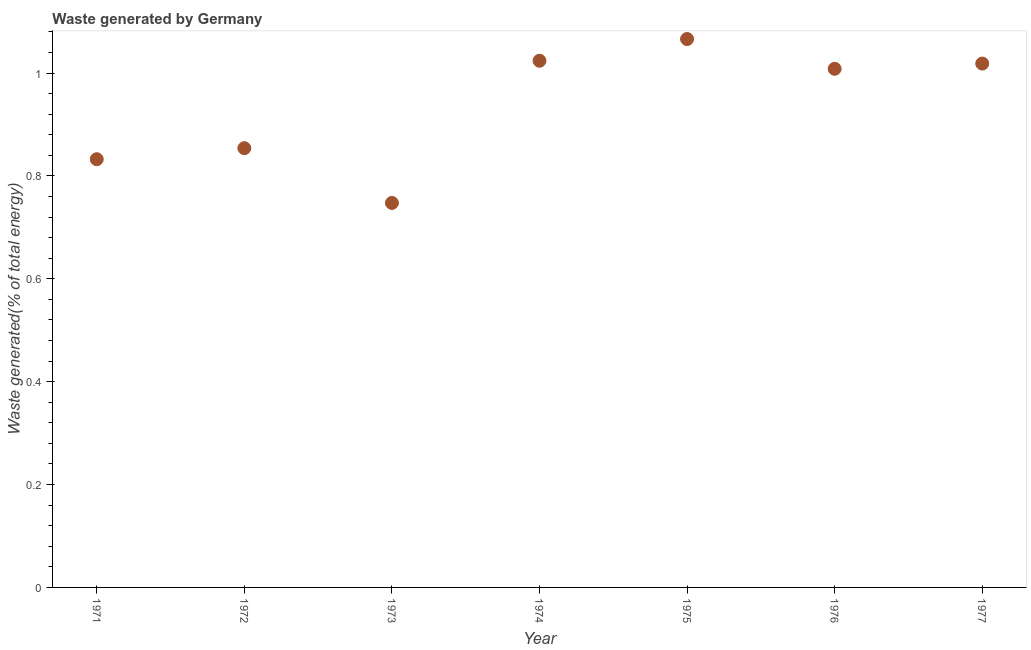What is the amount of waste generated in 1977?
Your answer should be compact. 1.02. Across all years, what is the maximum amount of waste generated?
Your response must be concise. 1.07. Across all years, what is the minimum amount of waste generated?
Provide a short and direct response. 0.75. In which year was the amount of waste generated maximum?
Offer a terse response. 1975. What is the sum of the amount of waste generated?
Your answer should be compact. 6.55. What is the difference between the amount of waste generated in 1971 and 1977?
Make the answer very short. -0.19. What is the average amount of waste generated per year?
Your answer should be compact. 0.94. What is the median amount of waste generated?
Your answer should be very brief. 1.01. Do a majority of the years between 1971 and 1973 (inclusive) have amount of waste generated greater than 0.8400000000000001 %?
Make the answer very short. No. What is the ratio of the amount of waste generated in 1976 to that in 1977?
Your answer should be very brief. 0.99. What is the difference between the highest and the second highest amount of waste generated?
Keep it short and to the point. 0.04. What is the difference between the highest and the lowest amount of waste generated?
Keep it short and to the point. 0.32. In how many years, is the amount of waste generated greater than the average amount of waste generated taken over all years?
Your answer should be compact. 4. Does the amount of waste generated monotonically increase over the years?
Keep it short and to the point. No. How many dotlines are there?
Your answer should be very brief. 1. What is the difference between two consecutive major ticks on the Y-axis?
Your response must be concise. 0.2. What is the title of the graph?
Your answer should be very brief. Waste generated by Germany. What is the label or title of the X-axis?
Provide a short and direct response. Year. What is the label or title of the Y-axis?
Offer a very short reply. Waste generated(% of total energy). What is the Waste generated(% of total energy) in 1971?
Provide a short and direct response. 0.83. What is the Waste generated(% of total energy) in 1972?
Keep it short and to the point. 0.85. What is the Waste generated(% of total energy) in 1973?
Offer a terse response. 0.75. What is the Waste generated(% of total energy) in 1974?
Offer a very short reply. 1.02. What is the Waste generated(% of total energy) in 1975?
Your answer should be compact. 1.07. What is the Waste generated(% of total energy) in 1976?
Offer a terse response. 1.01. What is the Waste generated(% of total energy) in 1977?
Give a very brief answer. 1.02. What is the difference between the Waste generated(% of total energy) in 1971 and 1972?
Make the answer very short. -0.02. What is the difference between the Waste generated(% of total energy) in 1971 and 1973?
Your answer should be very brief. 0.09. What is the difference between the Waste generated(% of total energy) in 1971 and 1974?
Make the answer very short. -0.19. What is the difference between the Waste generated(% of total energy) in 1971 and 1975?
Offer a terse response. -0.23. What is the difference between the Waste generated(% of total energy) in 1971 and 1976?
Make the answer very short. -0.18. What is the difference between the Waste generated(% of total energy) in 1971 and 1977?
Offer a terse response. -0.19. What is the difference between the Waste generated(% of total energy) in 1972 and 1973?
Your answer should be very brief. 0.11. What is the difference between the Waste generated(% of total energy) in 1972 and 1974?
Provide a succinct answer. -0.17. What is the difference between the Waste generated(% of total energy) in 1972 and 1975?
Your answer should be very brief. -0.21. What is the difference between the Waste generated(% of total energy) in 1972 and 1976?
Your response must be concise. -0.15. What is the difference between the Waste generated(% of total energy) in 1972 and 1977?
Your answer should be very brief. -0.16. What is the difference between the Waste generated(% of total energy) in 1973 and 1974?
Make the answer very short. -0.28. What is the difference between the Waste generated(% of total energy) in 1973 and 1975?
Your answer should be compact. -0.32. What is the difference between the Waste generated(% of total energy) in 1973 and 1976?
Offer a very short reply. -0.26. What is the difference between the Waste generated(% of total energy) in 1973 and 1977?
Offer a terse response. -0.27. What is the difference between the Waste generated(% of total energy) in 1974 and 1975?
Provide a succinct answer. -0.04. What is the difference between the Waste generated(% of total energy) in 1974 and 1976?
Provide a short and direct response. 0.02. What is the difference between the Waste generated(% of total energy) in 1974 and 1977?
Offer a terse response. 0.01. What is the difference between the Waste generated(% of total energy) in 1975 and 1976?
Provide a short and direct response. 0.06. What is the difference between the Waste generated(% of total energy) in 1975 and 1977?
Provide a succinct answer. 0.05. What is the difference between the Waste generated(% of total energy) in 1976 and 1977?
Keep it short and to the point. -0.01. What is the ratio of the Waste generated(% of total energy) in 1971 to that in 1973?
Make the answer very short. 1.11. What is the ratio of the Waste generated(% of total energy) in 1971 to that in 1974?
Offer a terse response. 0.81. What is the ratio of the Waste generated(% of total energy) in 1971 to that in 1975?
Give a very brief answer. 0.78. What is the ratio of the Waste generated(% of total energy) in 1971 to that in 1976?
Your response must be concise. 0.83. What is the ratio of the Waste generated(% of total energy) in 1971 to that in 1977?
Offer a terse response. 0.82. What is the ratio of the Waste generated(% of total energy) in 1972 to that in 1973?
Provide a short and direct response. 1.14. What is the ratio of the Waste generated(% of total energy) in 1972 to that in 1974?
Ensure brevity in your answer.  0.83. What is the ratio of the Waste generated(% of total energy) in 1972 to that in 1975?
Make the answer very short. 0.8. What is the ratio of the Waste generated(% of total energy) in 1972 to that in 1976?
Your answer should be compact. 0.85. What is the ratio of the Waste generated(% of total energy) in 1972 to that in 1977?
Your response must be concise. 0.84. What is the ratio of the Waste generated(% of total energy) in 1973 to that in 1974?
Your response must be concise. 0.73. What is the ratio of the Waste generated(% of total energy) in 1973 to that in 1975?
Keep it short and to the point. 0.7. What is the ratio of the Waste generated(% of total energy) in 1973 to that in 1976?
Give a very brief answer. 0.74. What is the ratio of the Waste generated(% of total energy) in 1973 to that in 1977?
Provide a succinct answer. 0.73. What is the ratio of the Waste generated(% of total energy) in 1975 to that in 1976?
Your answer should be compact. 1.06. What is the ratio of the Waste generated(% of total energy) in 1975 to that in 1977?
Provide a succinct answer. 1.05. 